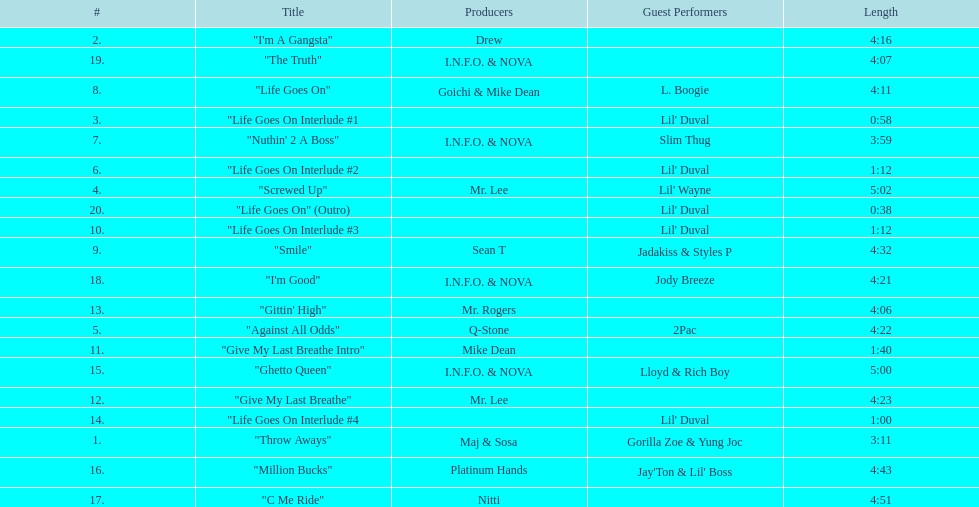How many tracks on trae's album "life goes on"? 20. 